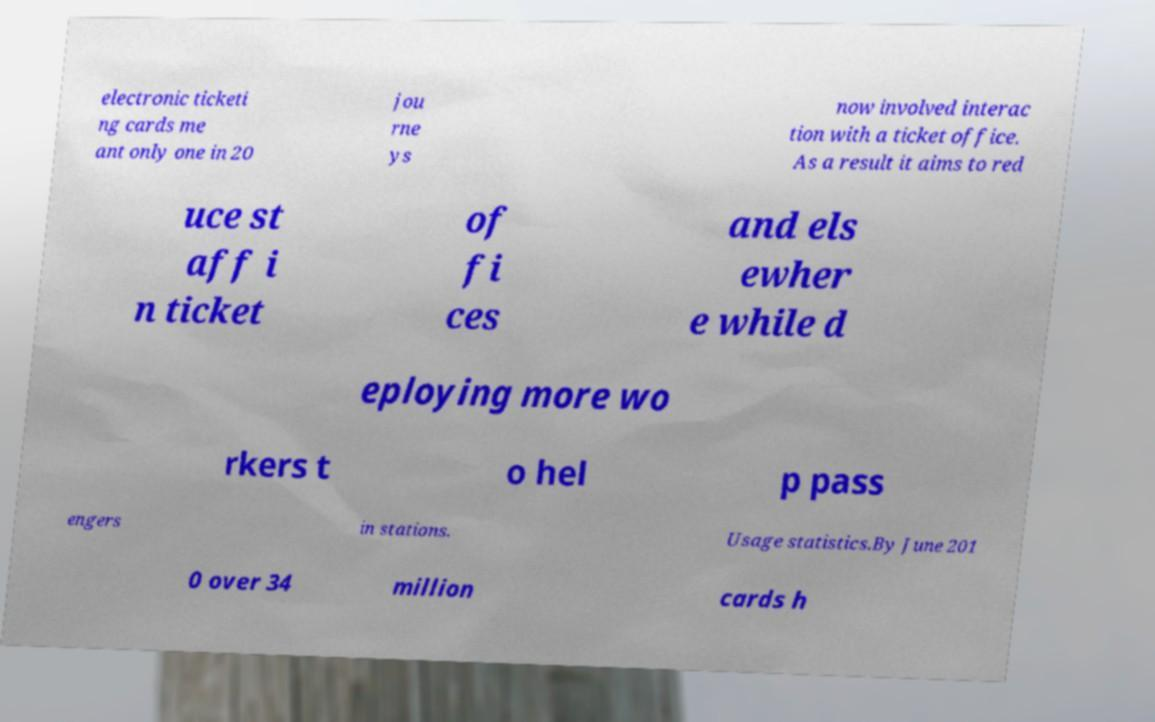Please read and relay the text visible in this image. What does it say? electronic ticketi ng cards me ant only one in 20 jou rne ys now involved interac tion with a ticket office. As a result it aims to red uce st aff i n ticket of fi ces and els ewher e while d eploying more wo rkers t o hel p pass engers in stations. Usage statistics.By June 201 0 over 34 million cards h 